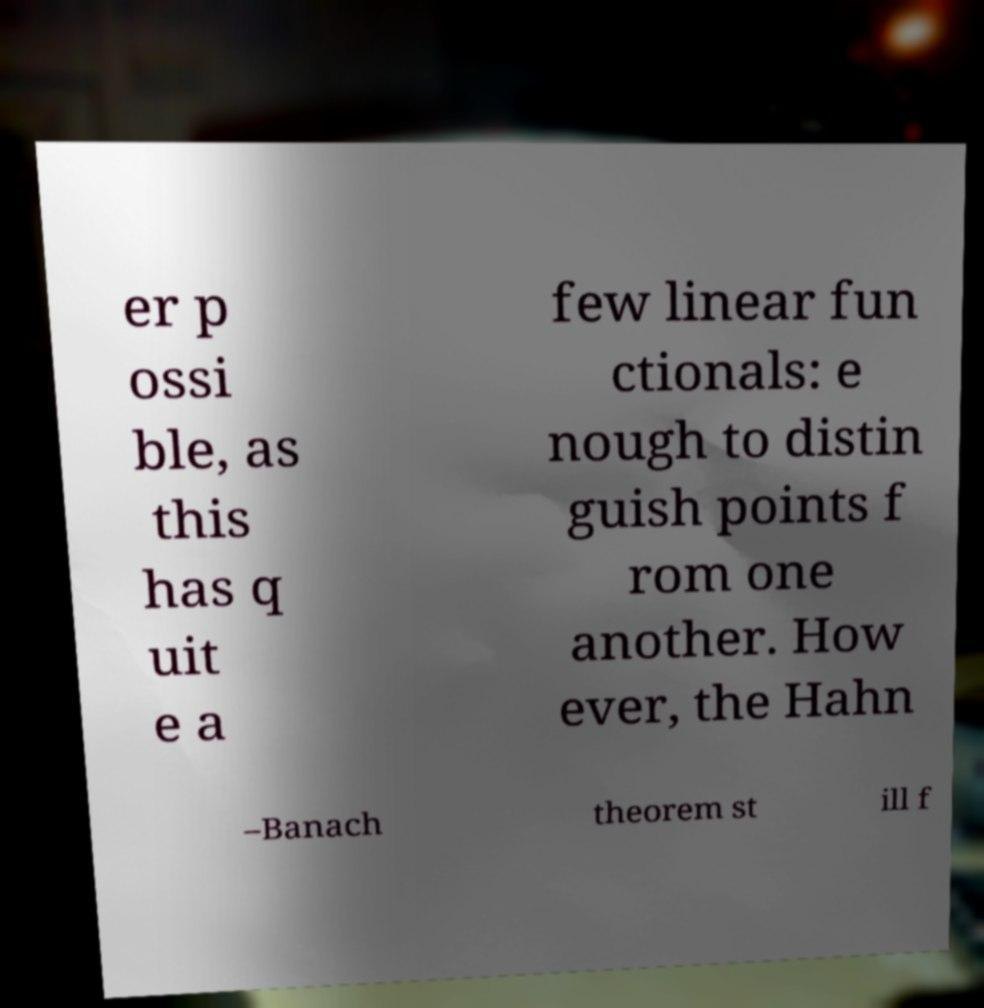Please identify and transcribe the text found in this image. er p ossi ble, as this has q uit e a few linear fun ctionals: e nough to distin guish points f rom one another. How ever, the Hahn –Banach theorem st ill f 